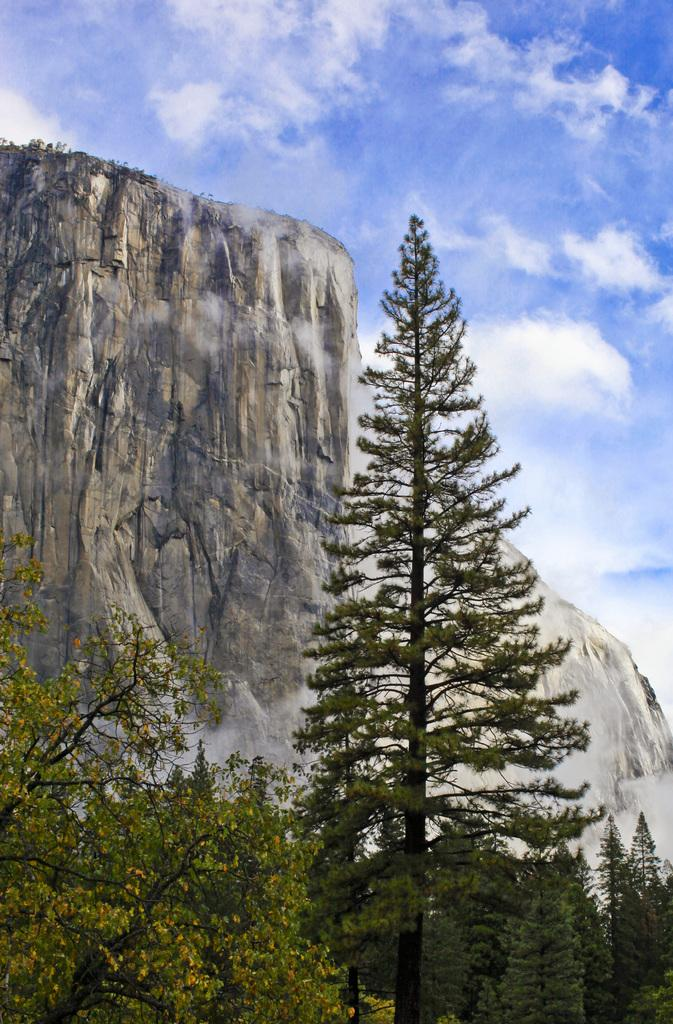What type of vegetation is visible in the image? There are trees in the image. What can be seen in the background of the image? There are hills visible in the background of the image. What part of the natural environment is visible in the image? The sky is visible in the background of the image. Can you see any drops of water falling from the trees in the image? There is no mention of any drops of water falling from the trees in the image. Is there a rifle visible in the image? There is no rifle present in the image. 